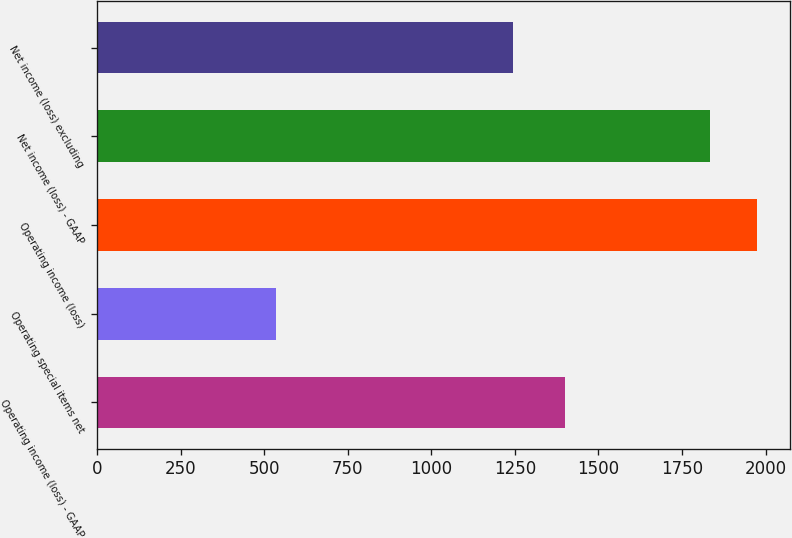<chart> <loc_0><loc_0><loc_500><loc_500><bar_chart><fcel>Operating income (loss) - GAAP<fcel>Operating special items net<fcel>Operating income (loss)<fcel>Net income (loss) - GAAP<fcel>Net income (loss) excluding<nl><fcel>1399<fcel>536<fcel>1973.9<fcel>1834<fcel>1244<nl></chart> 